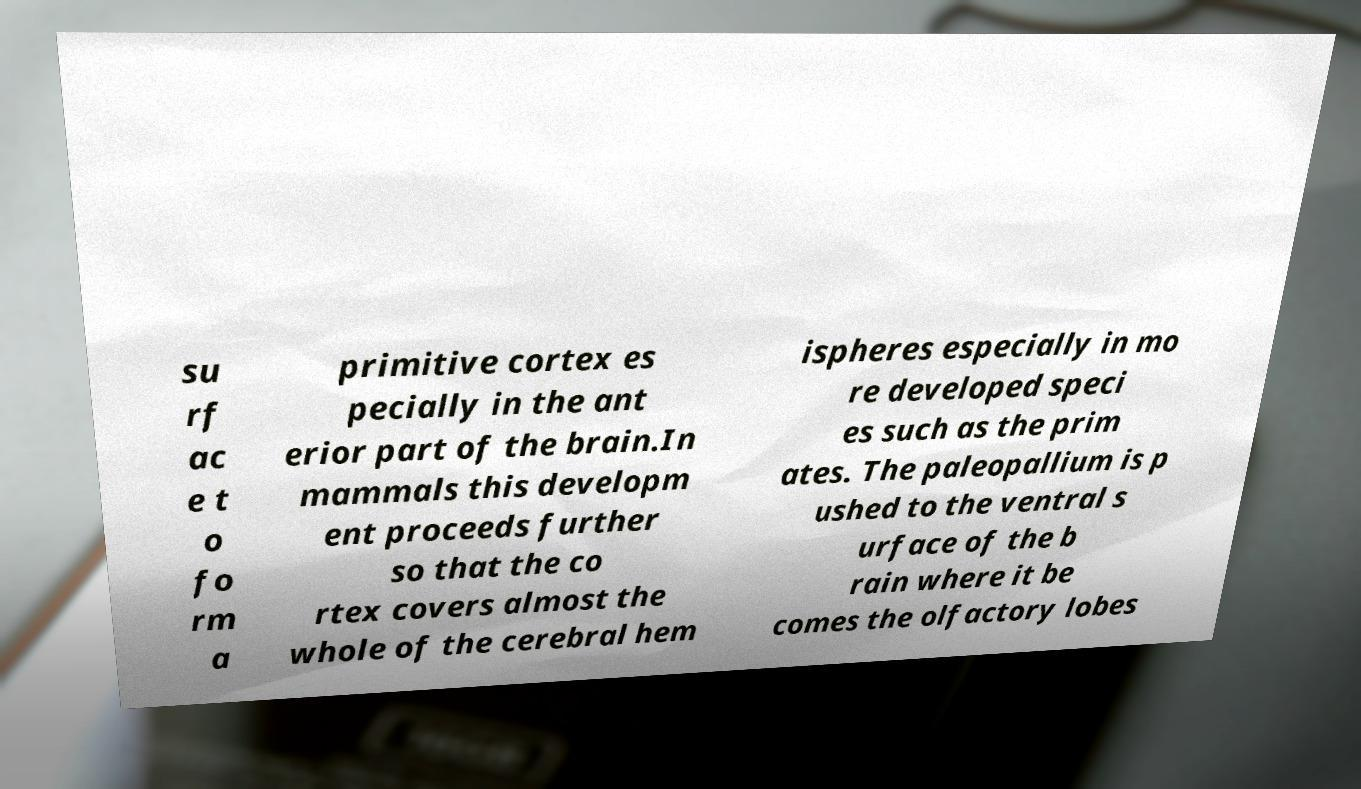Can you accurately transcribe the text from the provided image for me? su rf ac e t o fo rm a primitive cortex es pecially in the ant erior part of the brain.In mammals this developm ent proceeds further so that the co rtex covers almost the whole of the cerebral hem ispheres especially in mo re developed speci es such as the prim ates. The paleopallium is p ushed to the ventral s urface of the b rain where it be comes the olfactory lobes 